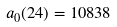<formula> <loc_0><loc_0><loc_500><loc_500>a _ { 0 } ( 2 4 ) = 1 0 8 3 8</formula> 